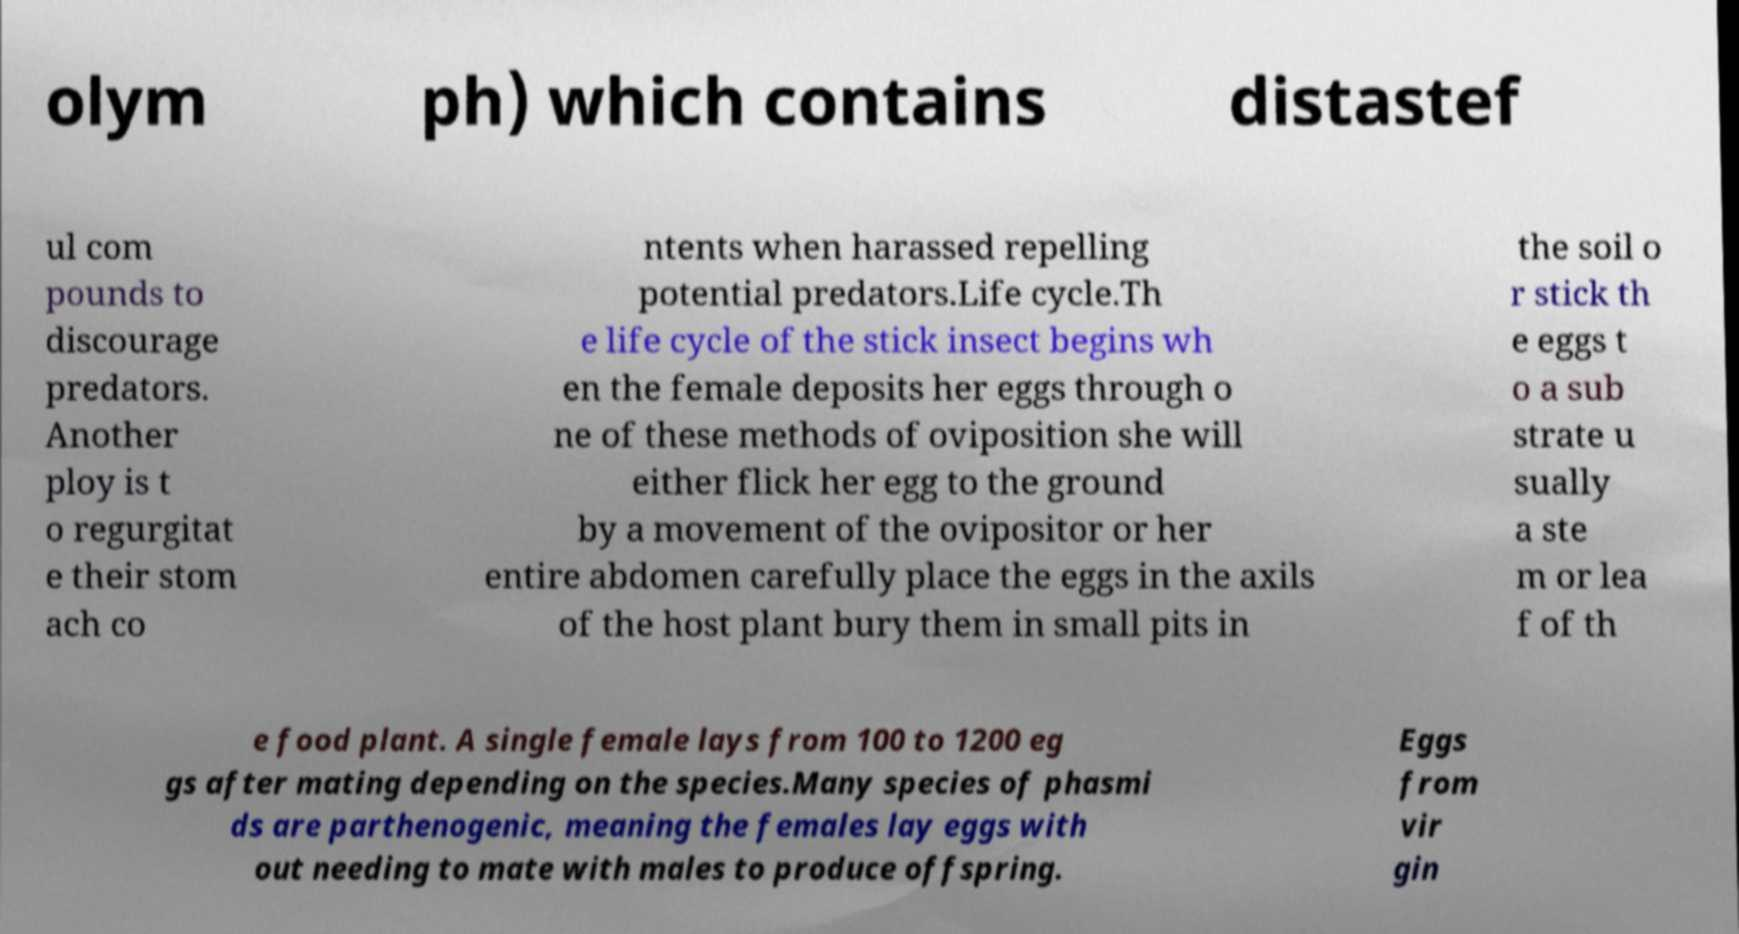Please read and relay the text visible in this image. What does it say? olym ph) which contains distastef ul com pounds to discourage predators. Another ploy is t o regurgitat e their stom ach co ntents when harassed repelling potential predators.Life cycle.Th e life cycle of the stick insect begins wh en the female deposits her eggs through o ne of these methods of oviposition she will either flick her egg to the ground by a movement of the ovipositor or her entire abdomen carefully place the eggs in the axils of the host plant bury them in small pits in the soil o r stick th e eggs t o a sub strate u sually a ste m or lea f of th e food plant. A single female lays from 100 to 1200 eg gs after mating depending on the species.Many species of phasmi ds are parthenogenic, meaning the females lay eggs with out needing to mate with males to produce offspring. Eggs from vir gin 